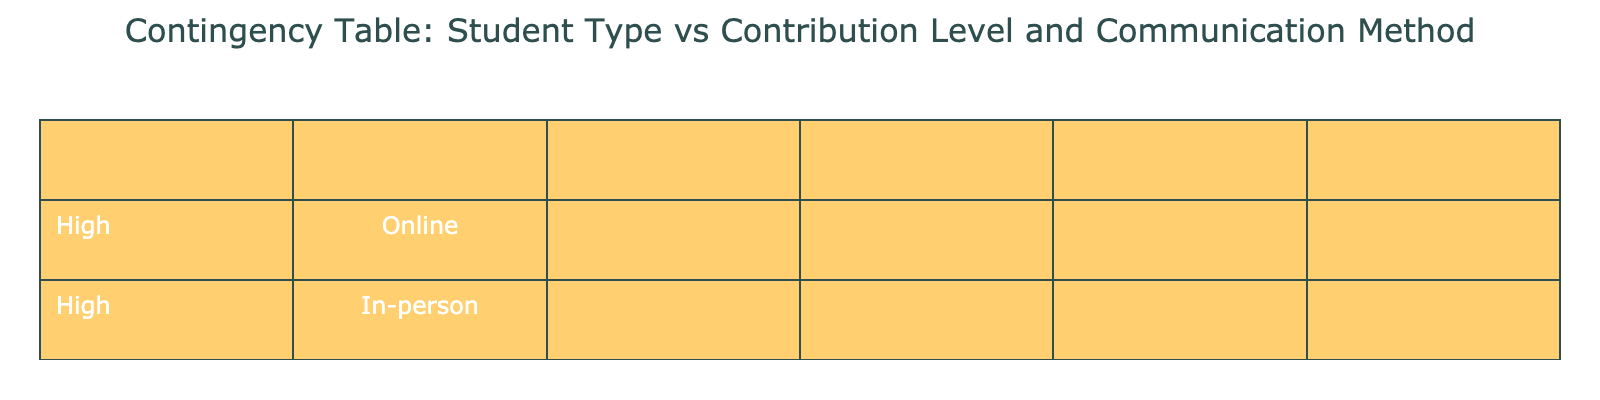What is the contribution level of local students using online communication? From the table, we can look at the Communication Method column and find "Online" under the Local category. There is only one entry for Local with Online communication, which shows a contribution level of "Low."
Answer: Low How many international students have a high contribution level? In the Contribution Level column for international students, we count the entries with "High." There are 2 instances (Group 1 and Group 7) where international students have a high contribution level.
Answer: 2 Is the statement "All local students use in-person communication" true? By checking the table, we can see the Communication Method for local students. There are local students in both "Online" and "Hybrid," indicating that the statement is false.
Answer: No What is the total number of students in the group with medium contribution levels? We look at the Contribution Level column and find "Medium." For both international and local students, there are a total of 4 entries (Groups 2, 3, 6, and 9) with medium contributions.
Answer: 4 Which communication method has the highest contribution level for local students? Checking the table under the Local category, we see "High" contribution levels using "In-person" communication in Groups 4 and 10. Therefore, In-person is the communication method with the highest contribution level for local students.
Answer: In-person 